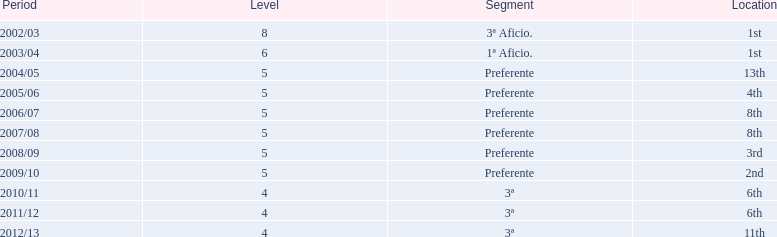Which seasons were played in tier four? 2010/11, 2011/12, 2012/13. Of these seasons, which resulted in 6th place? 2010/11, 2011/12. Which of the remaining happened last? 2011/12. 